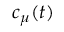<formula> <loc_0><loc_0><loc_500><loc_500>c _ { \mu } ( t )</formula> 